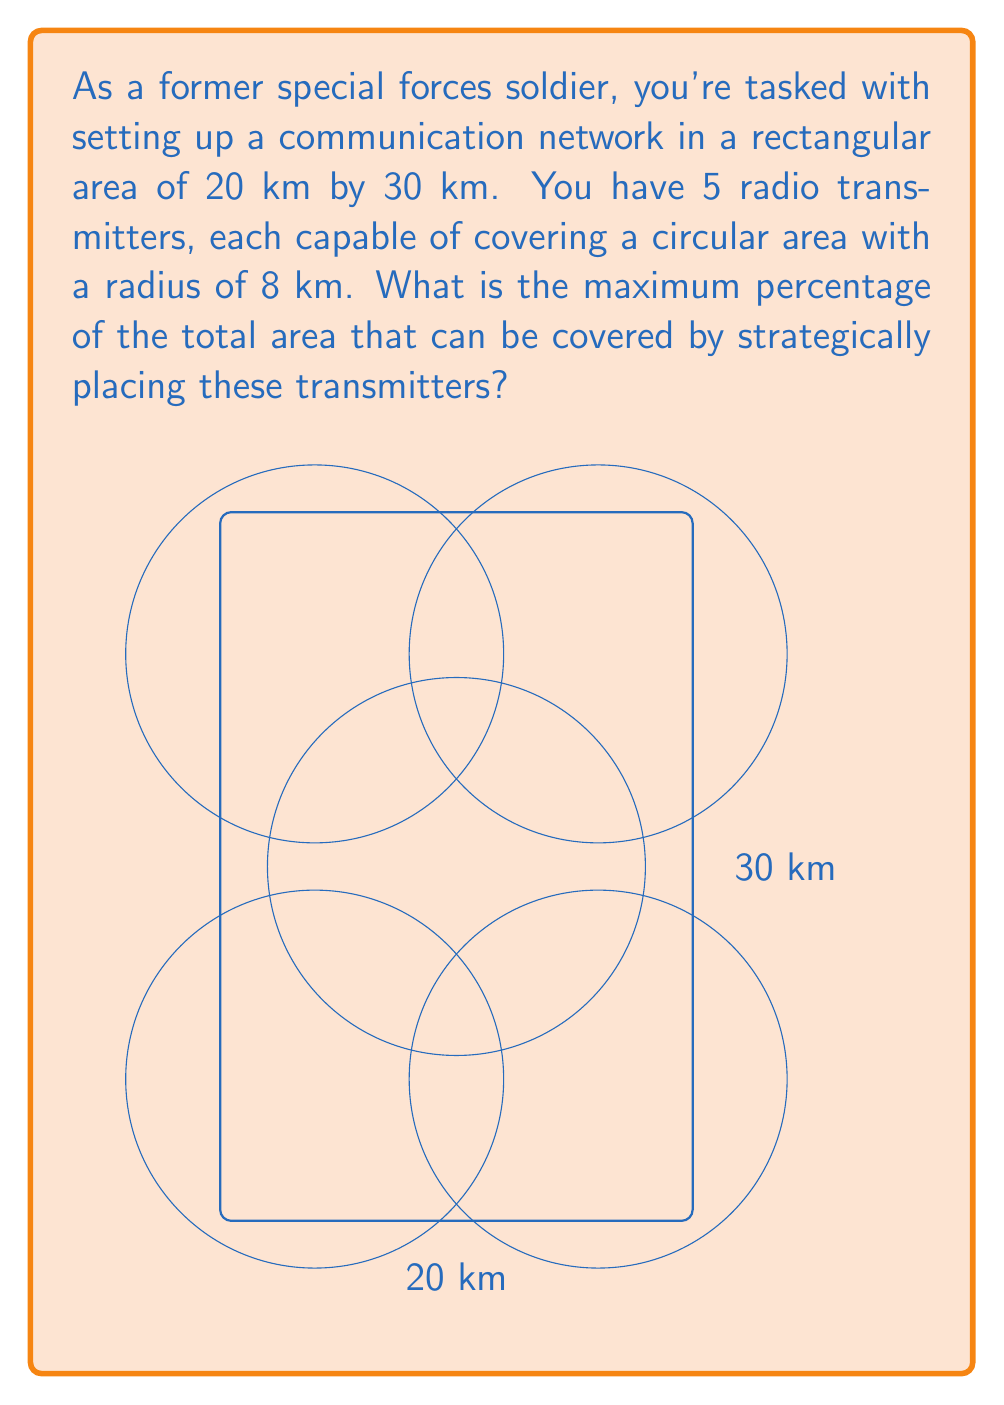Can you solve this math problem? Let's approach this step-by-step:

1) First, calculate the total area of the rectangular region:
   $$A_{total} = 20 \text{ km} \times 30 \text{ km} = 600 \text{ km}^2$$

2) Each transmitter covers a circular area. The area of a circle is given by $\pi r^2$:
   $$A_{transmitter} = \pi (8 \text{ km})^2 = 64\pi \text{ km}^2$$

3) If there was no overlap, the total area covered would be:
   $$A_{no overlap} = 5 \times 64\pi \text{ km}^2 = 320\pi \text{ km}^2$$

4) However, this is greater than the total area of the rectangle. In reality, the maximum coverage is achieved when the transmitters are placed to cover the entire rectangle with minimal overlap.

5) The optimal placement is to put four transmitters in the corners and one in the center, as shown in the diagram.

6) To calculate the actual coverage, we need to subtract the areas of overlap. The overlaps form lens shapes, which are complex to calculate exactly. However, we can approximate the coverage as the entire rectangular area.

7) Therefore, the maximum coverage is essentially the entire 600 km² area.

8) To calculate the percentage:
   $$\text{Percentage} = \frac{\text{Covered Area}}{\text{Total Area}} \times 100\% = \frac{600 \text{ km}^2}{600 \text{ km}^2} \times 100\% = 100\%$$
Answer: 100% 